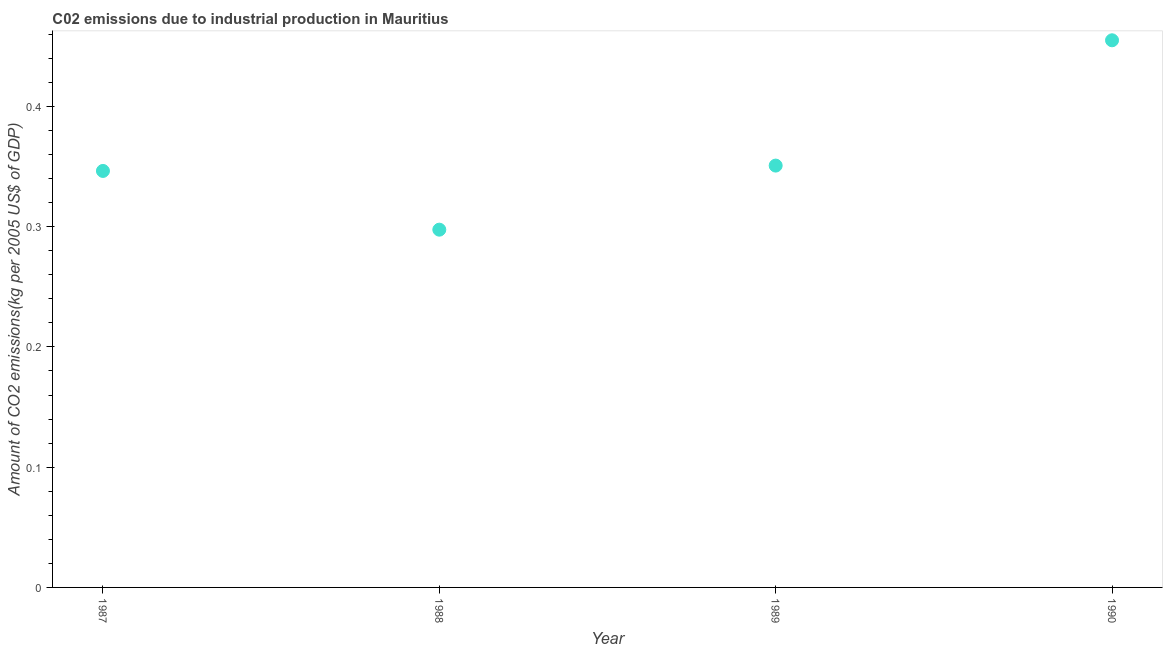What is the amount of co2 emissions in 1987?
Make the answer very short. 0.35. Across all years, what is the maximum amount of co2 emissions?
Provide a short and direct response. 0.45. Across all years, what is the minimum amount of co2 emissions?
Offer a very short reply. 0.3. In which year was the amount of co2 emissions minimum?
Offer a terse response. 1988. What is the sum of the amount of co2 emissions?
Make the answer very short. 1.45. What is the difference between the amount of co2 emissions in 1987 and 1988?
Make the answer very short. 0.05. What is the average amount of co2 emissions per year?
Keep it short and to the point. 0.36. What is the median amount of co2 emissions?
Keep it short and to the point. 0.35. What is the ratio of the amount of co2 emissions in 1987 to that in 1990?
Provide a succinct answer. 0.76. What is the difference between the highest and the second highest amount of co2 emissions?
Your answer should be compact. 0.1. What is the difference between the highest and the lowest amount of co2 emissions?
Your answer should be compact. 0.16. In how many years, is the amount of co2 emissions greater than the average amount of co2 emissions taken over all years?
Offer a terse response. 1. How many years are there in the graph?
Give a very brief answer. 4. What is the difference between two consecutive major ticks on the Y-axis?
Give a very brief answer. 0.1. Does the graph contain any zero values?
Your answer should be very brief. No. What is the title of the graph?
Keep it short and to the point. C02 emissions due to industrial production in Mauritius. What is the label or title of the Y-axis?
Make the answer very short. Amount of CO2 emissions(kg per 2005 US$ of GDP). What is the Amount of CO2 emissions(kg per 2005 US$ of GDP) in 1987?
Your answer should be very brief. 0.35. What is the Amount of CO2 emissions(kg per 2005 US$ of GDP) in 1988?
Ensure brevity in your answer.  0.3. What is the Amount of CO2 emissions(kg per 2005 US$ of GDP) in 1989?
Provide a succinct answer. 0.35. What is the Amount of CO2 emissions(kg per 2005 US$ of GDP) in 1990?
Provide a succinct answer. 0.45. What is the difference between the Amount of CO2 emissions(kg per 2005 US$ of GDP) in 1987 and 1988?
Offer a terse response. 0.05. What is the difference between the Amount of CO2 emissions(kg per 2005 US$ of GDP) in 1987 and 1989?
Provide a succinct answer. -0. What is the difference between the Amount of CO2 emissions(kg per 2005 US$ of GDP) in 1987 and 1990?
Your answer should be very brief. -0.11. What is the difference between the Amount of CO2 emissions(kg per 2005 US$ of GDP) in 1988 and 1989?
Keep it short and to the point. -0.05. What is the difference between the Amount of CO2 emissions(kg per 2005 US$ of GDP) in 1988 and 1990?
Provide a short and direct response. -0.16. What is the difference between the Amount of CO2 emissions(kg per 2005 US$ of GDP) in 1989 and 1990?
Provide a succinct answer. -0.1. What is the ratio of the Amount of CO2 emissions(kg per 2005 US$ of GDP) in 1987 to that in 1988?
Offer a very short reply. 1.16. What is the ratio of the Amount of CO2 emissions(kg per 2005 US$ of GDP) in 1987 to that in 1989?
Offer a very short reply. 0.99. What is the ratio of the Amount of CO2 emissions(kg per 2005 US$ of GDP) in 1987 to that in 1990?
Your answer should be very brief. 0.76. What is the ratio of the Amount of CO2 emissions(kg per 2005 US$ of GDP) in 1988 to that in 1989?
Your answer should be very brief. 0.85. What is the ratio of the Amount of CO2 emissions(kg per 2005 US$ of GDP) in 1988 to that in 1990?
Your answer should be compact. 0.65. What is the ratio of the Amount of CO2 emissions(kg per 2005 US$ of GDP) in 1989 to that in 1990?
Your response must be concise. 0.77. 